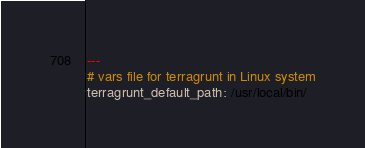<code> <loc_0><loc_0><loc_500><loc_500><_YAML_>---
# vars file for terragrunt in Linux system
terragrunt_default_path: /usr/local/bin/
</code> 